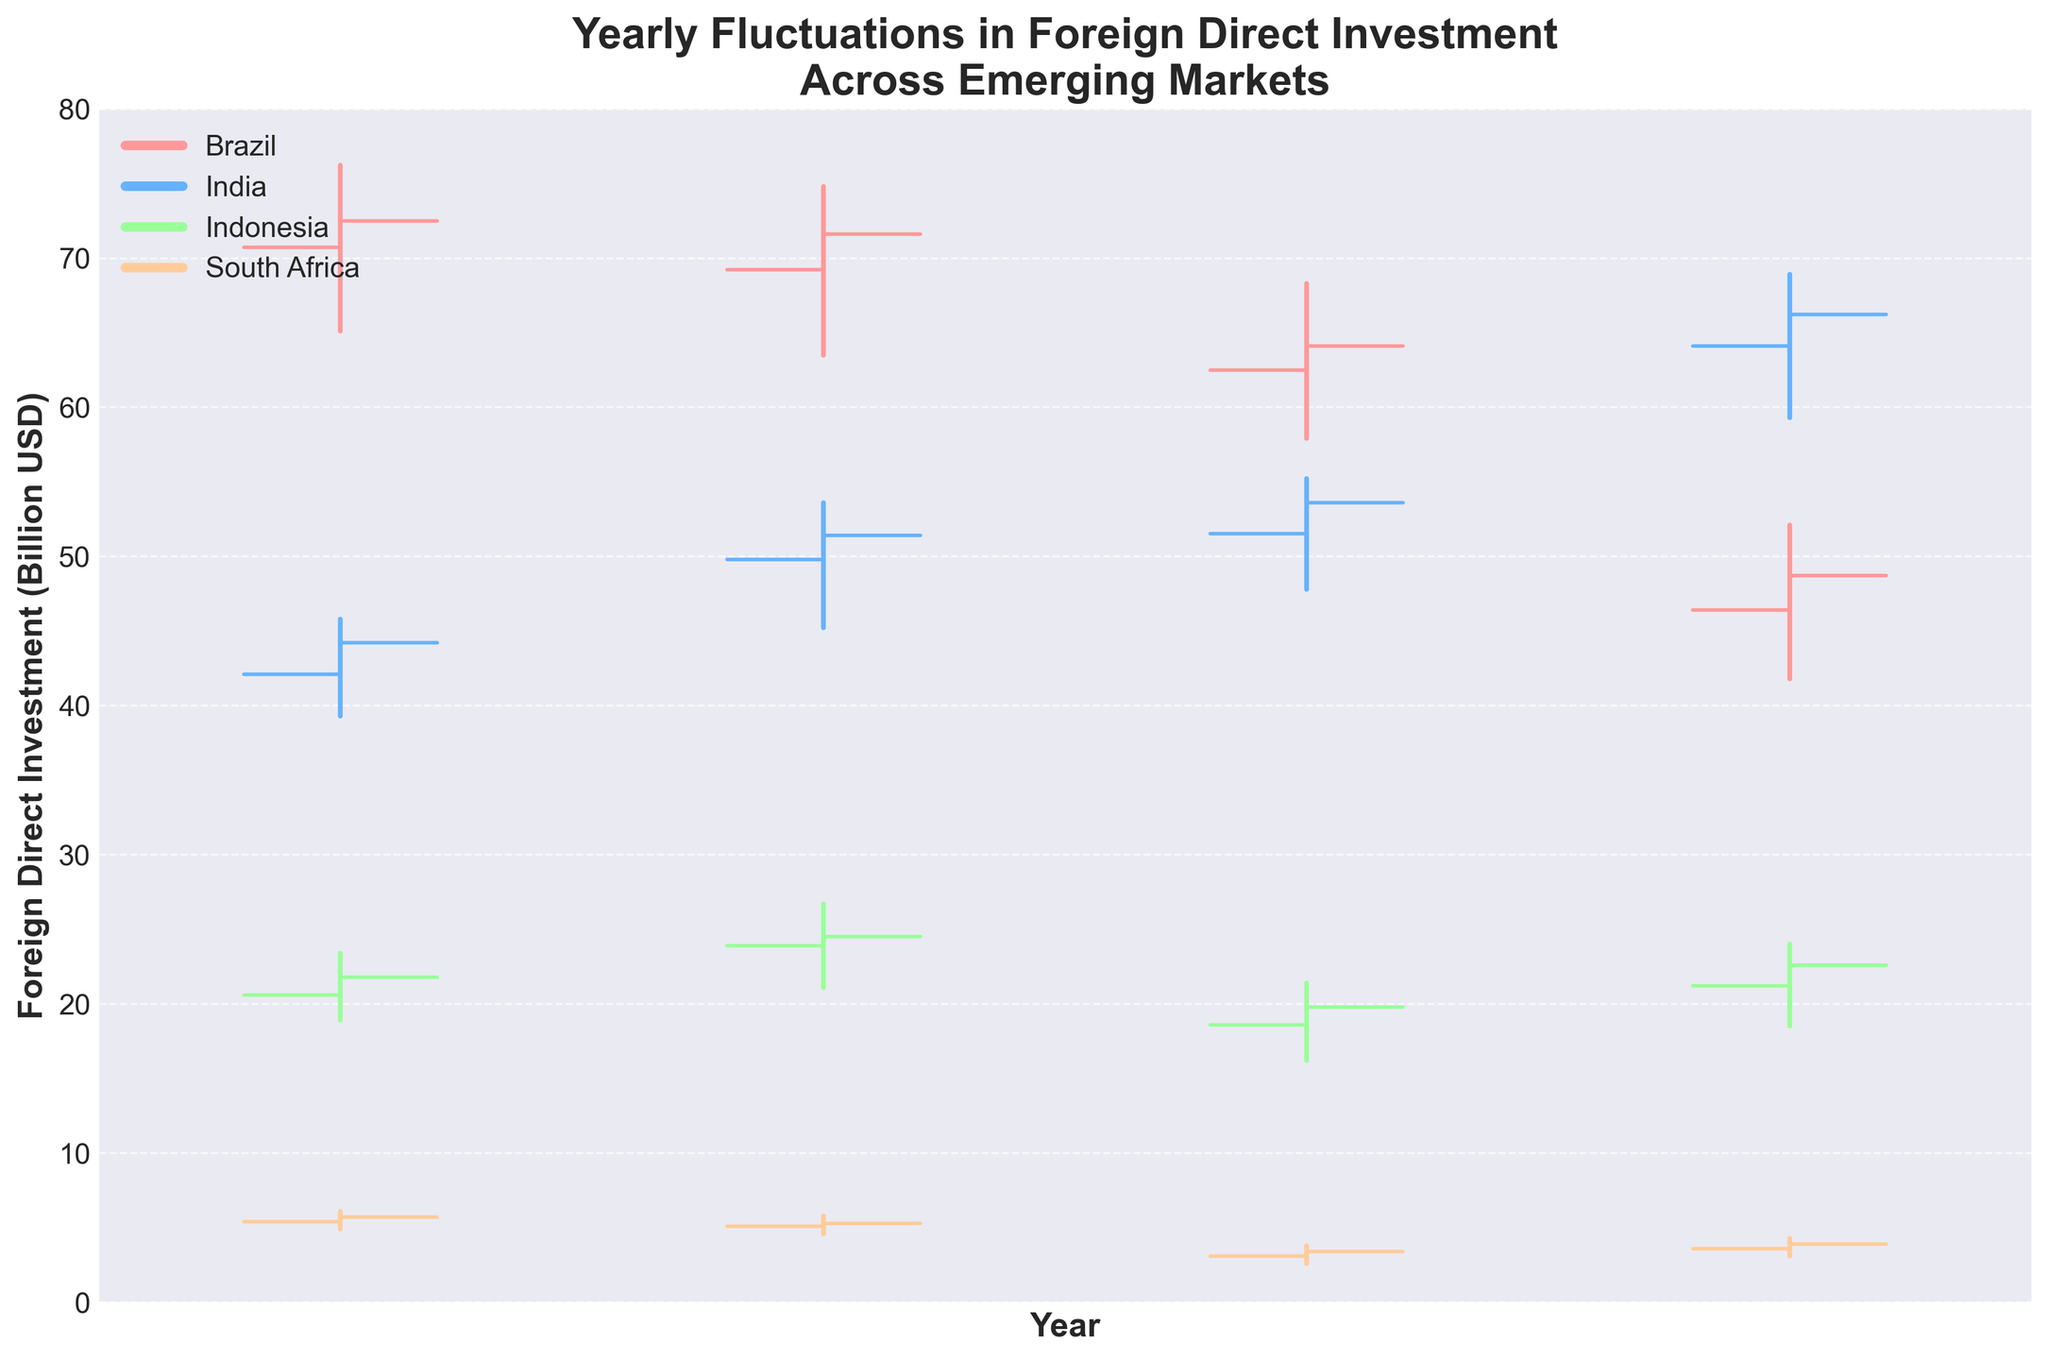What's the title of the figure? The title of the figure is usually found at the top of the plot and it summarizes the main content of the chart. In this case, the title is clearly displayed at the top.
Answer: "Yearly Fluctuations in Foreign Direct Investment Across Emerging Markets" What are the names of the countries represented in the figure? The names of the countries are indicated in the legend using different colors to represent each one. The legend is located at the upper left corner of the plot.
Answer: Brazil, India, Indonesia, South Africa Which country saw the highest Foreign Direct Investment (FDI) in 2021? To find this, look at the highest points of the bars for 2021. The highest FDI value in 2021 is marked at the highest point of one of the country's vertical lines.
Answer: India What is the general trend in FDI for Brazil from 2018 to 2021? To determine this, observe Brazil's vertical lines from 2018 to 2021. The trend can be described based on whether the lines generally go up, down, or fluctuate. Brazil shows a general decline in FDI over the years.
Answer: Declining Compare the FDI between Brazil and India in 2020. Which one had a lower closing value? Identify the closing values for Brazil and India by looking at the horizontal lines on the right side of the vertical lines for 2020. Compare these values to see which one is lower.
Answer: Brazil How much did the FDI open value for Indonesia decrease from 2019 to 2020? Look at the open values for Indonesia in 2019 and 2020. Subtract the 2020 value from the 2019 value to find the decrease. The open value decreased from 23.9 to 18.6.
Answer: 5.3 billion USD Which year had the lowest FDI for South Africa? Locate the lowest point of the vertical lines for each year for South Africa. The year with the lowest position indicates the year with the lowest FDI.
Answer: 2020 What was the difference in the high values of FDI between India and Indonesia in 2021? Look at the high values for India and Indonesia in 2021. Subtract Indonesia's high value from India's high value to find the difference. The high value for India is 68.9 and for Indonesia, it is 24.0.
Answer: 44.9 billion USD In which year did Brazil's FDI close higher than it opened? For Brazil, compare the open and close values year by year. The year when the close value is higher than the open value is the answer.
Answer: 2018 Which country had the most stable FDI (smallest range between high and low values) in 2019? Calculate the range (high minus low) for each country in 2019. The country with the smallest range had the most stable FDI.
Answer: South Africa 